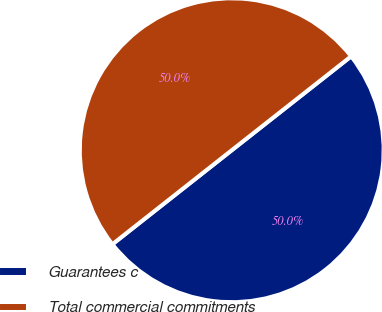<chart> <loc_0><loc_0><loc_500><loc_500><pie_chart><fcel>Guarantees c<fcel>Total commercial commitments<nl><fcel>49.99%<fcel>50.01%<nl></chart> 